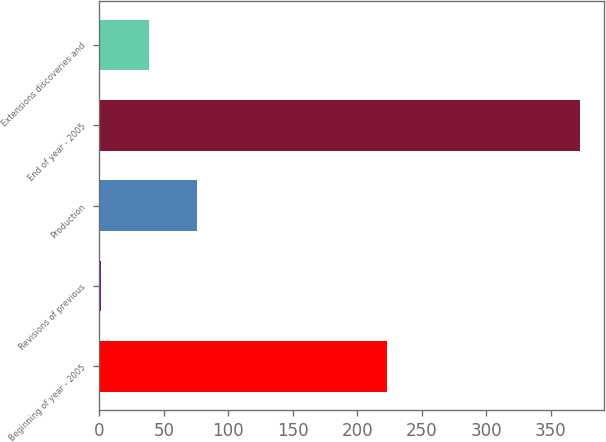Convert chart to OTSL. <chart><loc_0><loc_0><loc_500><loc_500><bar_chart><fcel>Beginning of year - 2005<fcel>Revisions of previous<fcel>Production<fcel>End of year - 2005<fcel>Extensions discoveries and<nl><fcel>223<fcel>1<fcel>75.4<fcel>373<fcel>38.2<nl></chart> 